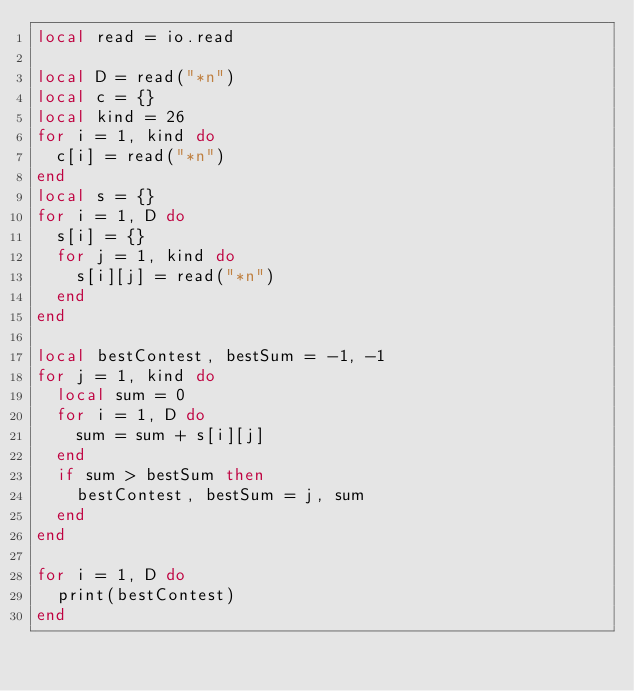<code> <loc_0><loc_0><loc_500><loc_500><_Lua_>local read = io.read

local D = read("*n")
local c = {}
local kind = 26
for i = 1, kind do
	c[i] = read("*n")
end
local s = {}
for i = 1, D do
	s[i] = {}
	for j = 1, kind do
		s[i][j] = read("*n")
	end
end

local bestContest, bestSum = -1, -1
for j = 1, kind do
	local sum = 0
	for i = 1, D do
		sum = sum + s[i][j]
	end
	if sum > bestSum then
		bestContest, bestSum = j, sum
	end
end

for i = 1, D do
	print(bestContest)
end
</code> 